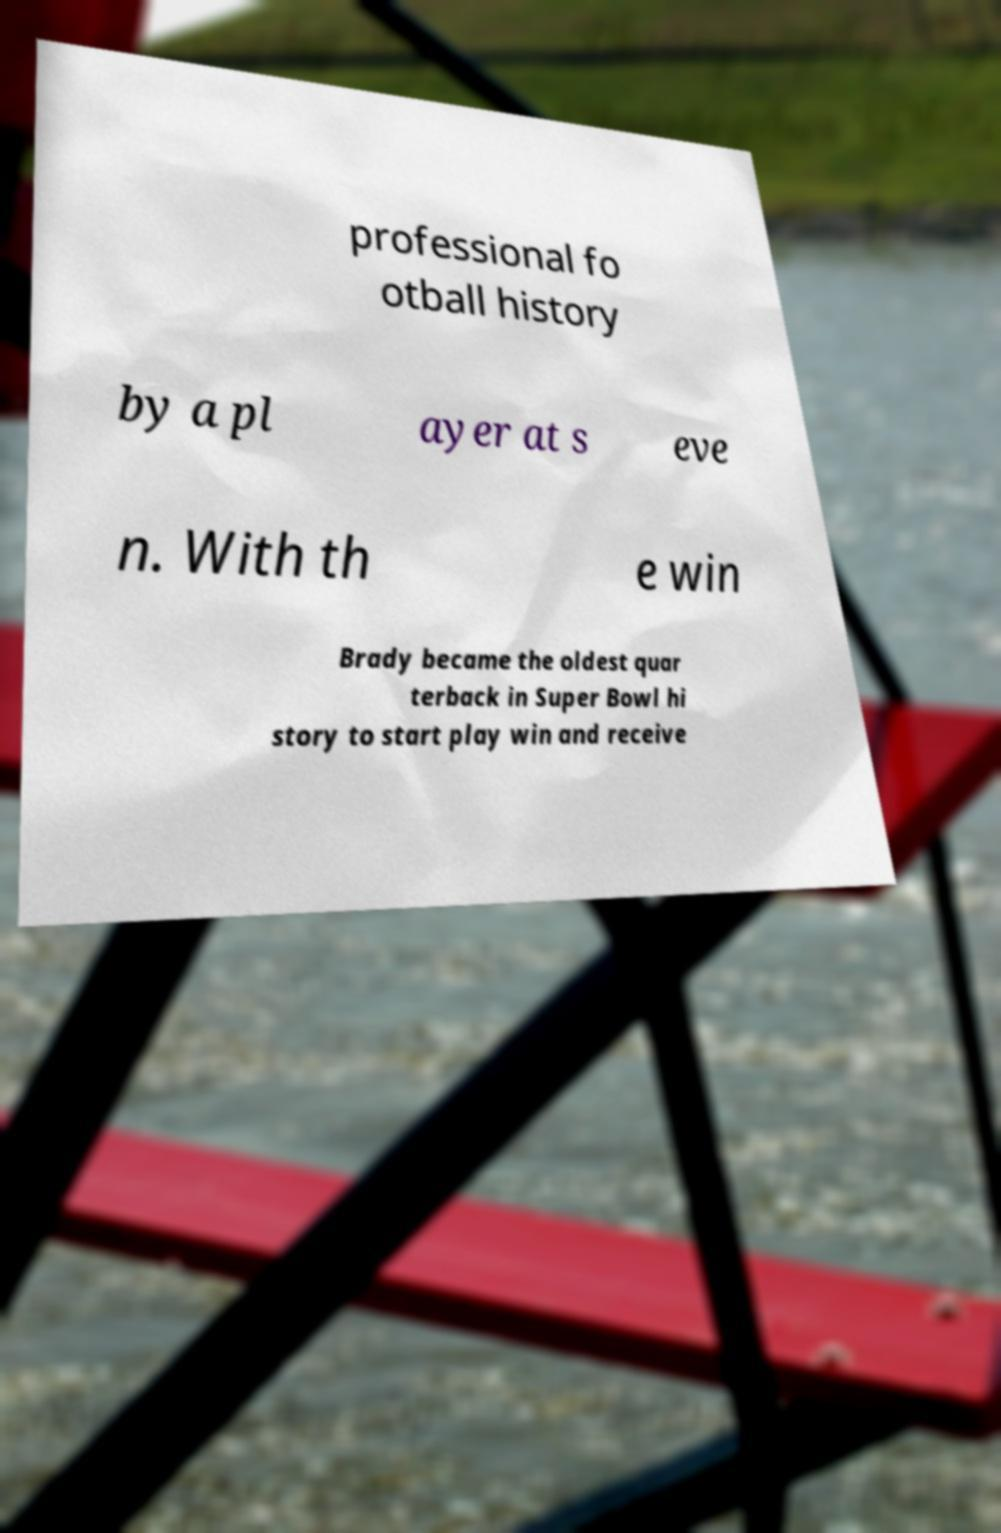Can you accurately transcribe the text from the provided image for me? professional fo otball history by a pl ayer at s eve n. With th e win Brady became the oldest quar terback in Super Bowl hi story to start play win and receive 